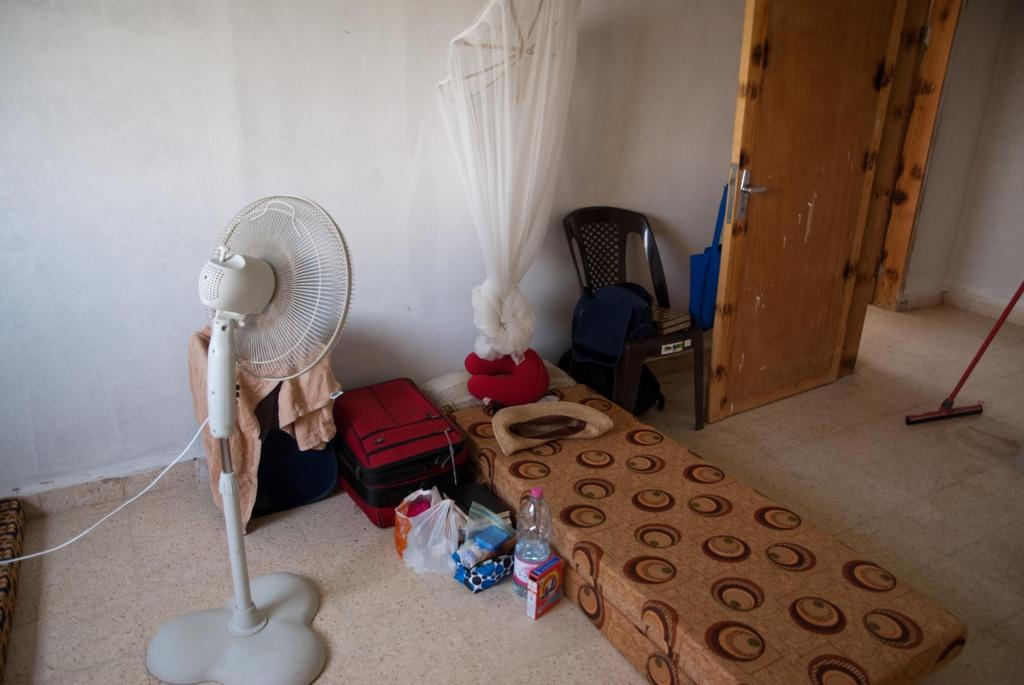What type of space is depicted in the image? There is a room in the image. What can be seen hanging in the room? There is a net in the room. What piece of furniture is present in the room? There is a bed, a chair, and a door in the room. What items are visible on the floor or a surface in the room? There is a bottle, a polythene cover, and a suitcase in the room. What type of box is used to store the breath in the image? There is no box or reference to breath in the image; it only features a room with various objects and furniture. 